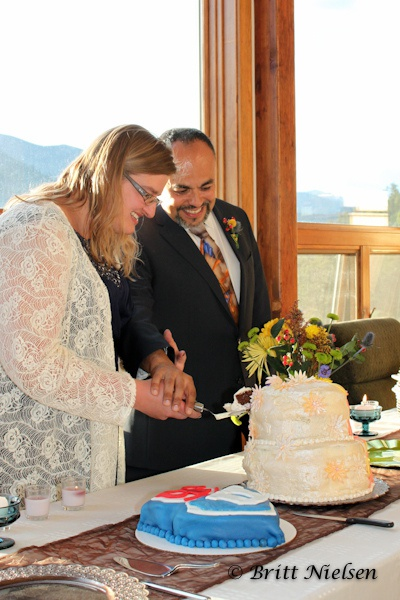Describe the objects in this image and their specific colors. I can see people in white, tan, darkgray, and gray tones, people in white, black, brown, and maroon tones, dining table in white, lightgray, darkgray, gray, and tan tones, cake in white, tan, and lightgray tones, and cake in white, teal, gray, and lightgray tones in this image. 